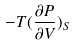Convert formula to latex. <formula><loc_0><loc_0><loc_500><loc_500>- T ( \frac { \partial P } { \partial V } ) _ { S }</formula> 